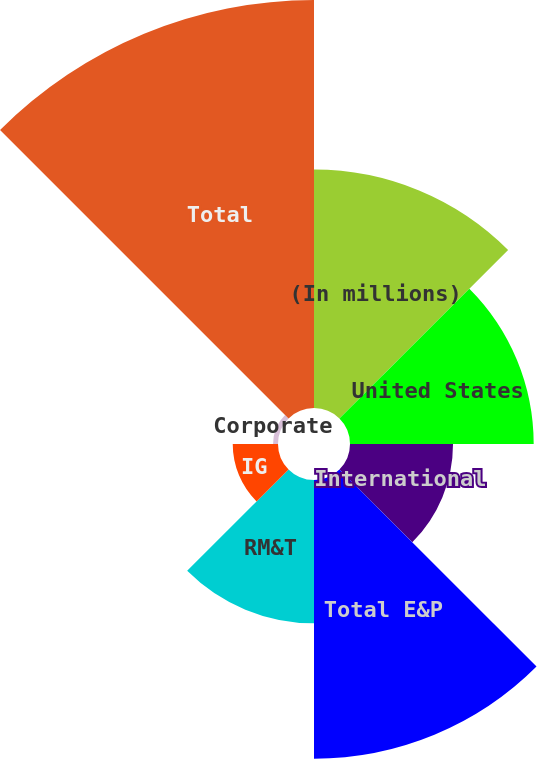Convert chart to OTSL. <chart><loc_0><loc_0><loc_500><loc_500><pie_chart><fcel>(In millions)<fcel>United States<fcel>International<fcel>Total E&P<fcel>RM&T<fcel>IG<fcel>Corporate<fcel>Total<nl><fcel>16.97%<fcel>13.07%<fcel>7.33%<fcel>19.83%<fcel>10.2%<fcel>3.22%<fcel>0.35%<fcel>29.03%<nl></chart> 